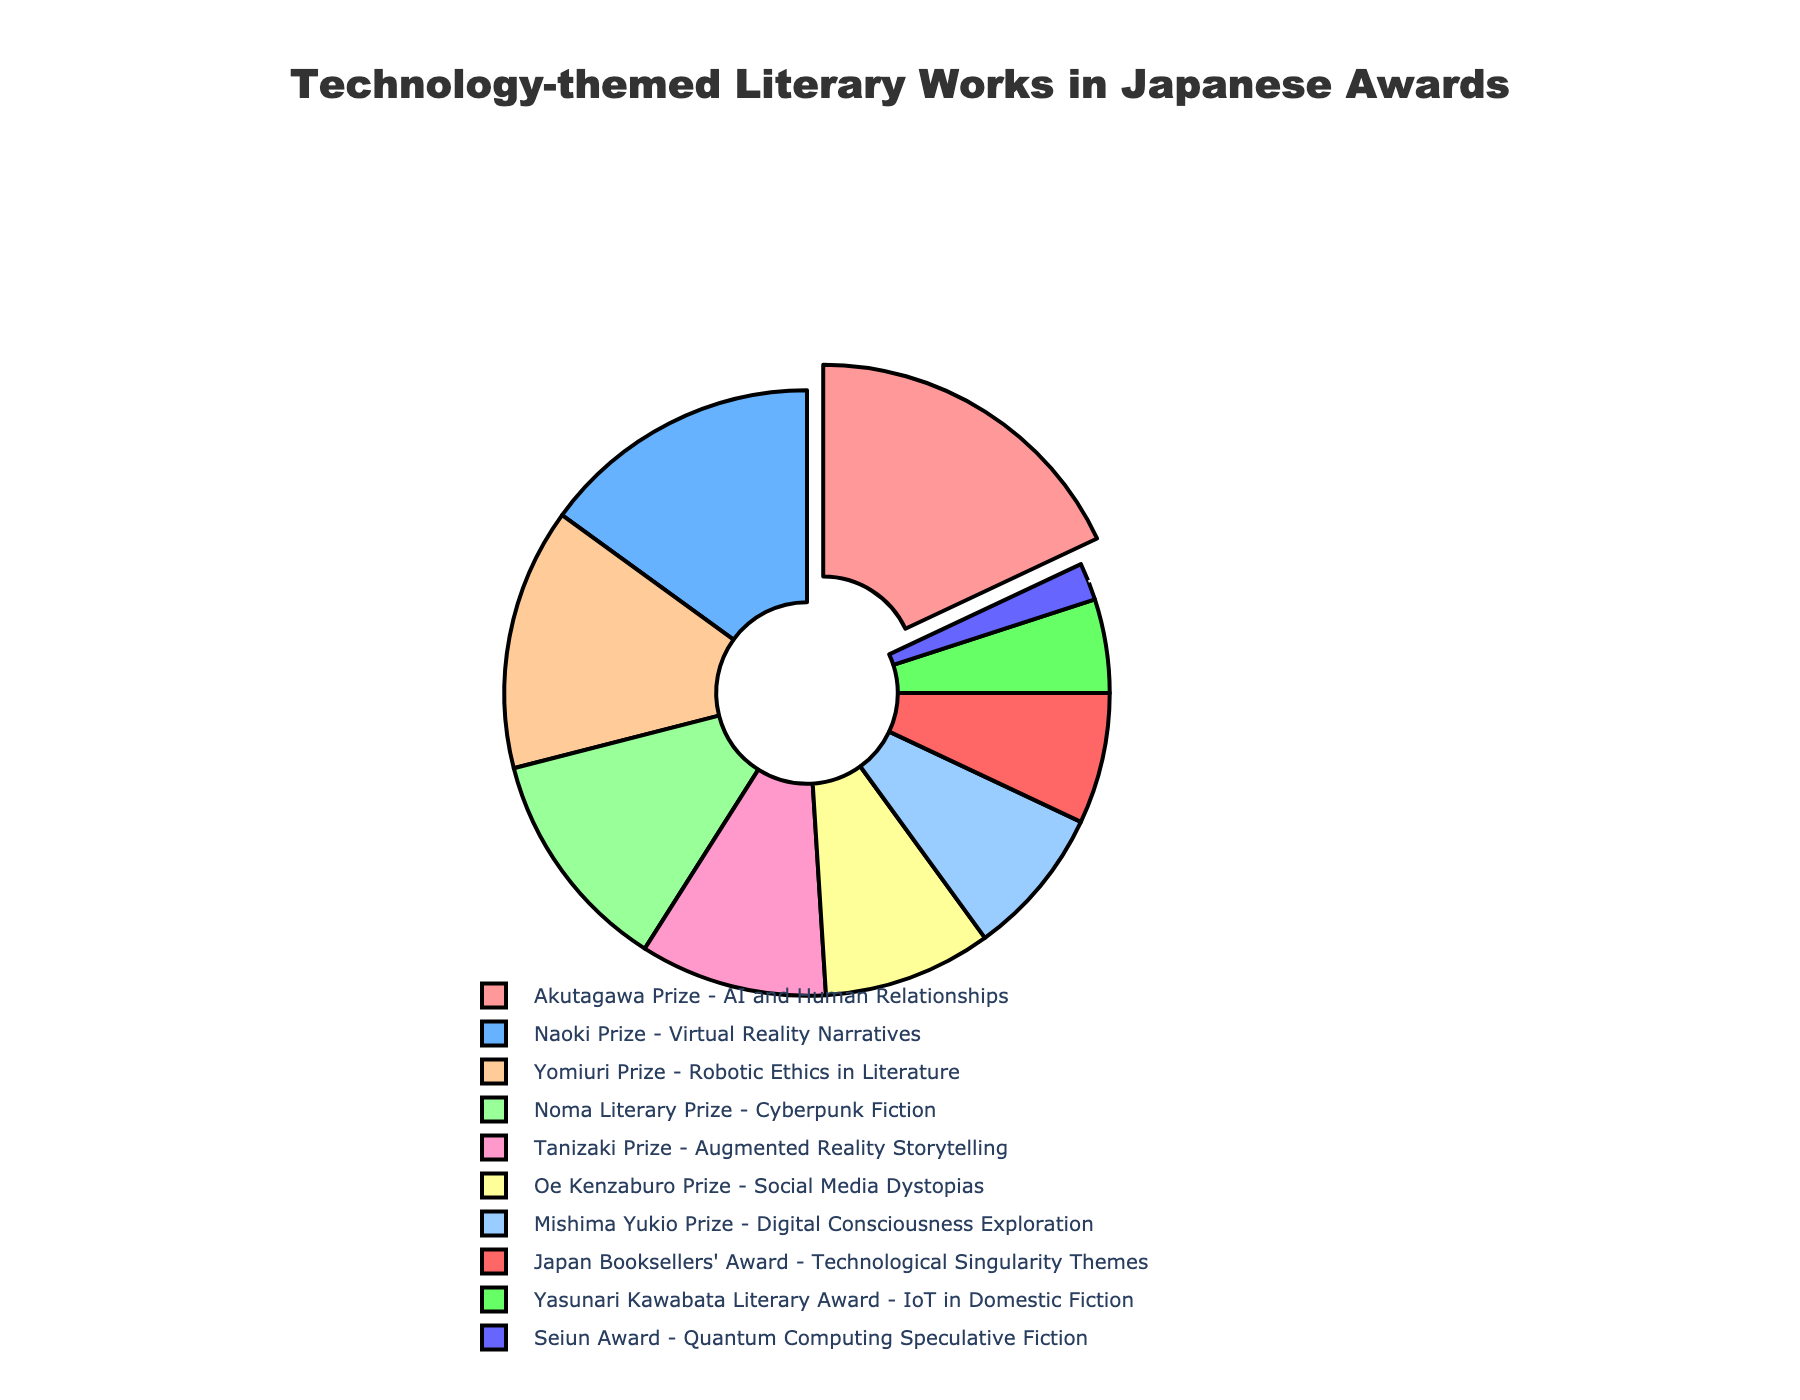Which award category represents the largest percentage of technology-themed literary works? The largest segment of the pie chart is pulled out, which represents the Akutagawa Prize - AI and Human Relationships at 18%.
Answer: Akutagawa Prize - AI and Human Relationships What is the combined percentage of the award categories that focus on AI and Human Relationships and Virtual Reality Narratives? According to the chart, the Akutagawa Prize - AI and Human Relationships is 18%, and the Naoki Prize - Virtual Reality Narratives is 15%. Adding these together, 18% + 15% = 33%.
Answer: 33% Which award categories have a percentage less than 10%? By reviewing the pie chart, the categories with less than 10% are the Mishima Yukio Prize - Digital Consciousness Exploration (8%), Oe Kenzaburo Prize - Social Media Dystopias (9%), Japan Booksellers' Award - Technological Singularity Themes (7%), Yasunari Kawabata Literary Award - IoT in Domestic Fiction (5%), and Seiun Award - Quantum Computing Speculative Fiction (2%).
Answer: Mishima Yukio Prize - Digital Consciousness Exploration, Oe Kenzaburo Prize - Social Media Dystopias, Japan Booksellers' Award - Technological Singularity Themes, Yasunari Kawabata Literary Award - IoT in Domestic Fiction, Seiun Award - Quantum Computing Speculative Fiction How many award categories are there in total? By counting the segments in the pie chart, there are 10 distinct categories listed.
Answer: 10 Which award category represents double the percentage of the Seiun Award - Quantum Computing Speculative Fiction? The Seiun Award - Quantum Computing Speculative Fiction is at 2%. Double of 2% is 4%, but since we only have a segment larger than that at 5%, the Yasunari Kawabata Literary Award - IoT in Domestic Fiction (5%) is the closest.
Answer: Yasunari Kawabata Literary Award - IoT in Domestic Fiction What is the difference in percentage between the Yomiuri Prize - Robotic Ethics in Literature and the Tanizaki Prize - Augmented Reality Storytelling? According to the chart, the Yomiuri Prize - Robotic Ethics in Literature is 14% and the Tanizaki Prize - Augmented Reality Storytelling is 10%. The difference is \(14% - 10% = 4%\).
Answer: 4% What percentage does the Cyberpunk Fiction category represent, and which award recognizes it? The Noma Literary Prize recognizes Cyberpunk Fiction, and it represents 12% of the pie chart.
Answer: 12%, Noma Literary Prize What is the sum of the percentages for the Mishima Yukio Prize and the Japan Booksellers' Award? The Mishima Yukio Prize is 8%, and the Japan Booksellers' Award is 7%. Adding these together, \(8% + 7% = 15%\).
Answer: 15% Which category that involves 'Reality Narratives' has a larger percentage, and what is that percentage? The two categories are the Naoki Prize - Virtual Reality Narratives at 15% and the Tanizaki Prize - Augmented Reality Storytelling at 10%. The larger percentage is 15% for the Naoki Prize - Virtual Reality Narratives.
Answer: Naoki Prize - Virtual Reality Narratives, 15% What is the average percentage of the categories focusing on various AI and Cyberpunk topics: Akutagawa Prize, Noma Literary Prize, Seiun Award? The percentages for these are Akutagawa Prize - AI and Human Relationships (18%), Noma Literary Prize - Cyberpunk Fiction (12%), and Seiun Award - Quantum Computing Speculative Fiction (2%). The sum of these percentages is \(18% + 12% + 2% = 32%\), and the average is \(32\% / 3 \approx 10.67\%\).
Answer: 10.67% 